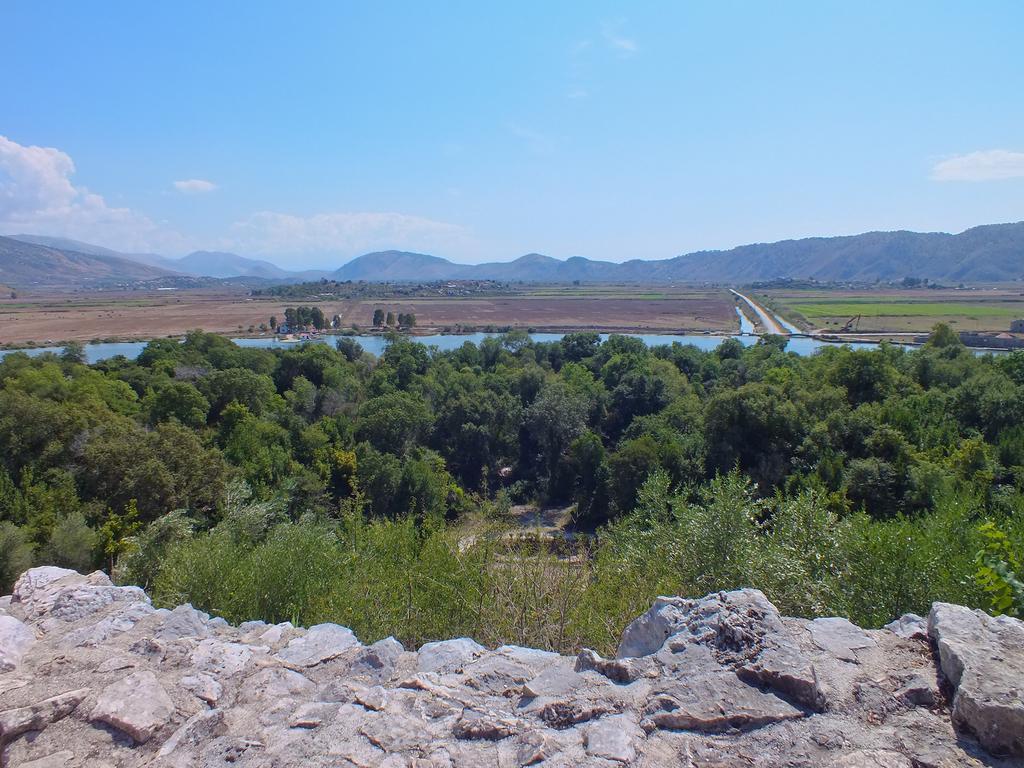Describe this image in one or two sentences. In this image we can see trees, water, mountains and sky. Those are clouds. Front of the image we can see a rock surface. 